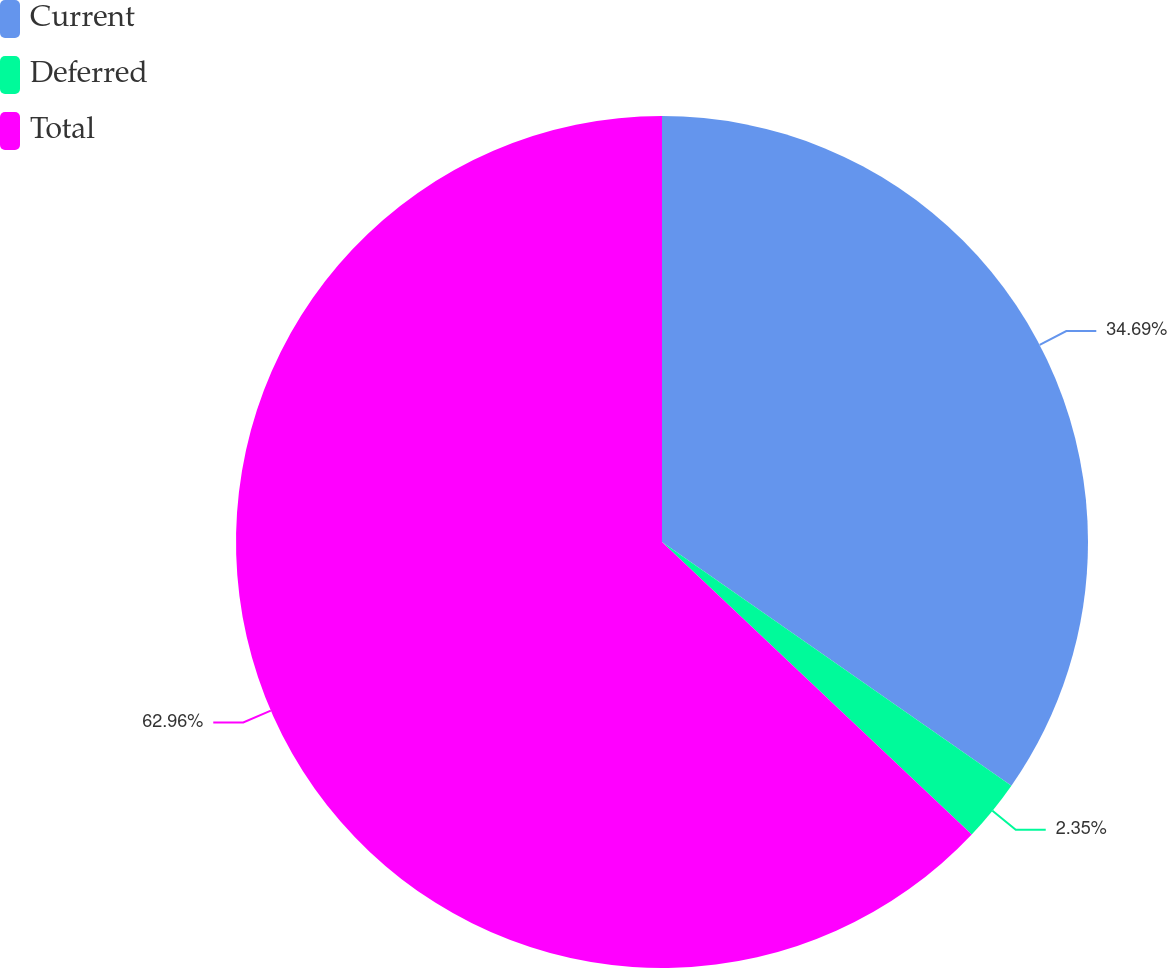<chart> <loc_0><loc_0><loc_500><loc_500><pie_chart><fcel>Current<fcel>Deferred<fcel>Total<nl><fcel>34.69%<fcel>2.35%<fcel>62.95%<nl></chart> 